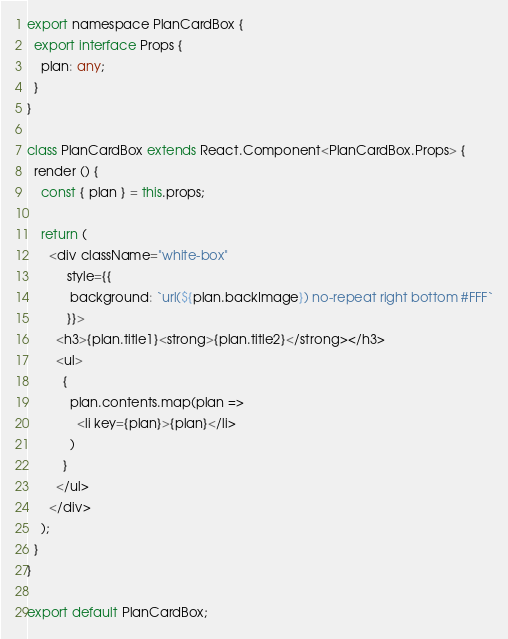Convert code to text. <code><loc_0><loc_0><loc_500><loc_500><_TypeScript_>
export namespace PlanCardBox {
  export interface Props {
    plan: any;
  }
}

class PlanCardBox extends React.Component<PlanCardBox.Props> {
  render () {
    const { plan } = this.props;

    return (
      <div className="white-box"
           style={{
            background: `url(${plan.backImage}) no-repeat right bottom #FFF`
           }}>
        <h3>{plan.title1}<strong>{plan.title2}</strong></h3>
        <ul>
          {
            plan.contents.map(plan =>
              <li key={plan}>{plan}</li>
            )
          }
        </ul>
      </div>
    );
  }
}

export default PlanCardBox;
</code> 